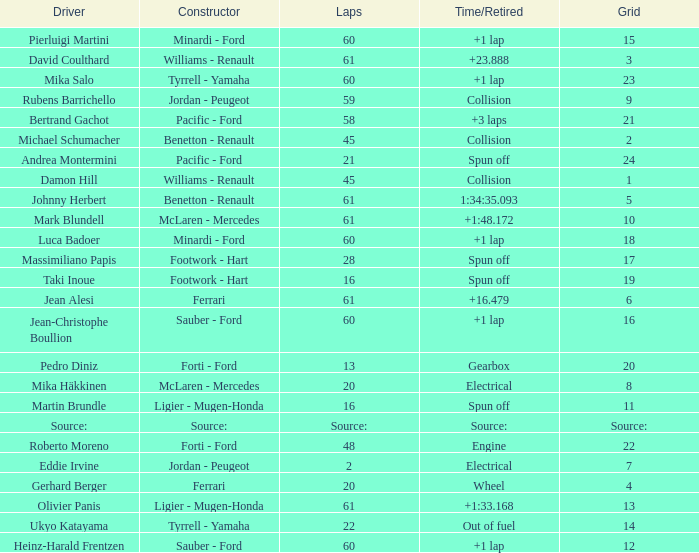How many laps does jean-christophe boullion have with a time/retired of +1 lap? 60.0. 